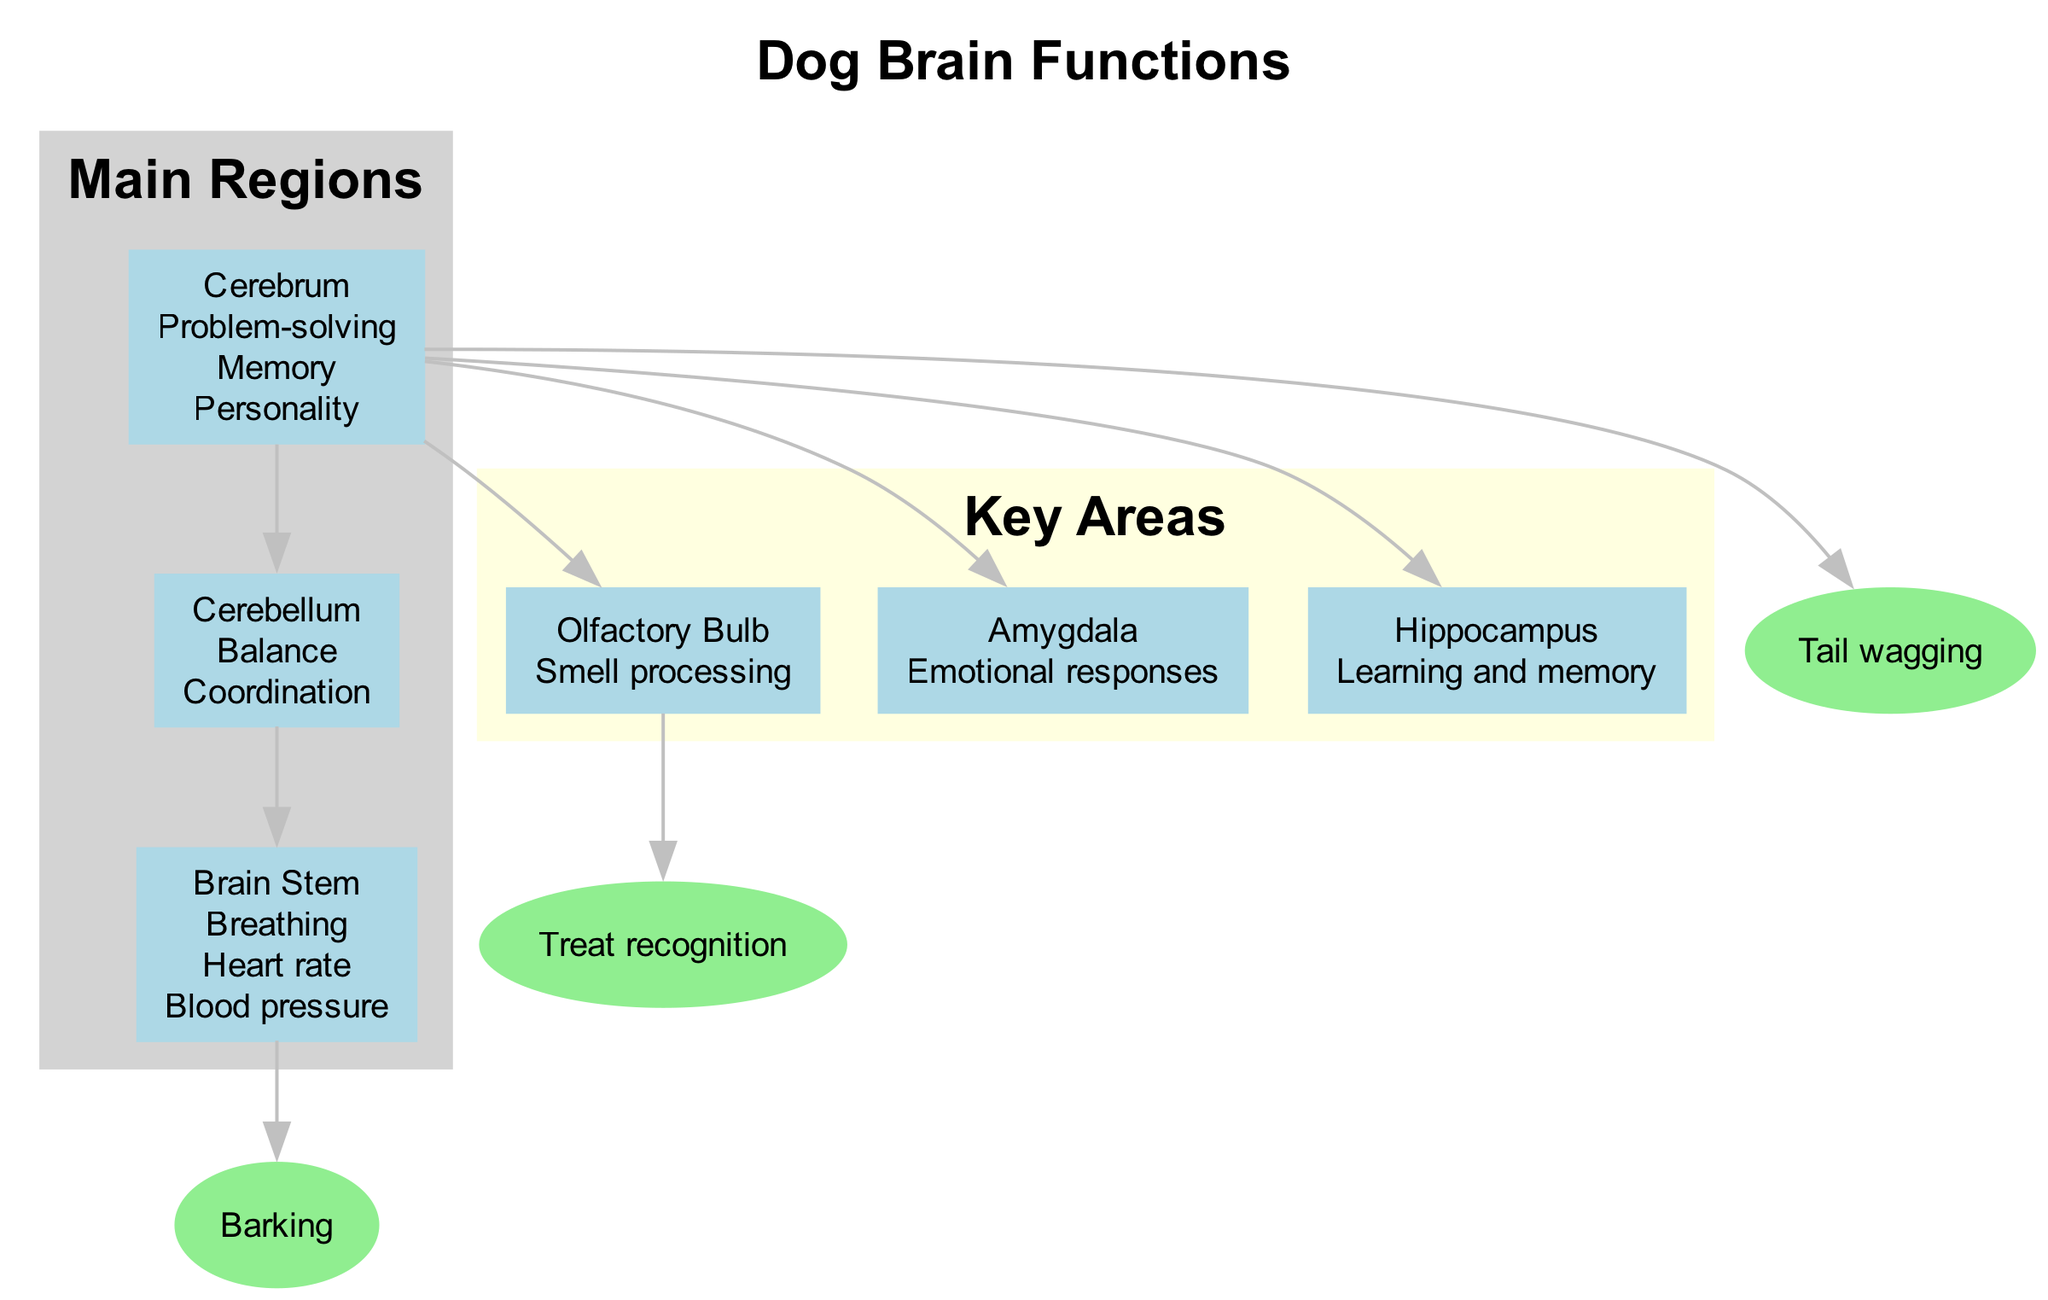What is the main function of the Cerebrum? The Cerebrum is responsible for problem-solving, memory, and personality, as indicated in the diagram.
Answer: Problem-solving, Memory, Personality How many main regions are shown in the diagram? The diagram displays three main regions: Cerebrum, Cerebellum, and Brain Stem. Therefore, the count is three.
Answer: 3 Which area is related to "Treat recognition"? The "Treat recognition" behavior is linked to the Olfactory Bulb according to its connection in the diagram.
Answer: Olfactory Bulb What function does the Amygdala serve? The Amygdala is indicated in the diagram as being responsible for emotional responses.
Answer: Emotional responses Which two main regions are connected directly? The main regions that are directly connected are the Cerebrum and Cerebellum as shown by the edge in the diagram.
Answer: Cerebrum and Cerebellum Which behavior is associated with the Brain Stem? The behavior "Barking" is associated with the Brain Stem as indicated in the diagram.
Answer: Barking What is the function of the Hippocampus? The diagram states that the Hippocampus is involved in learning and memory processes.
Answer: Learning and memory How does tail wagging relate to brain regions? Tail wagging is related to the Cerebrum as shown in the diagram connecting the behavior to this main region.
Answer: Cerebrum What is the role of the Cerebellum? The Cerebellum is highlighted for its functions in balance and coordination, which is clearly stated in the diagram.
Answer: Balance, Coordination 